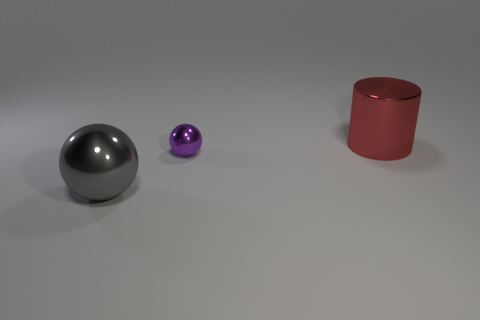Subtract all purple spheres. Subtract all red cylinders. How many spheres are left? 1 Add 2 big balls. How many objects exist? 5 Subtract all cylinders. How many objects are left? 2 Add 1 blue things. How many blue things exist? 1 Subtract 0 blue cylinders. How many objects are left? 3 Subtract all tiny purple shiny balls. Subtract all big red rubber cubes. How many objects are left? 2 Add 2 cylinders. How many cylinders are left? 3 